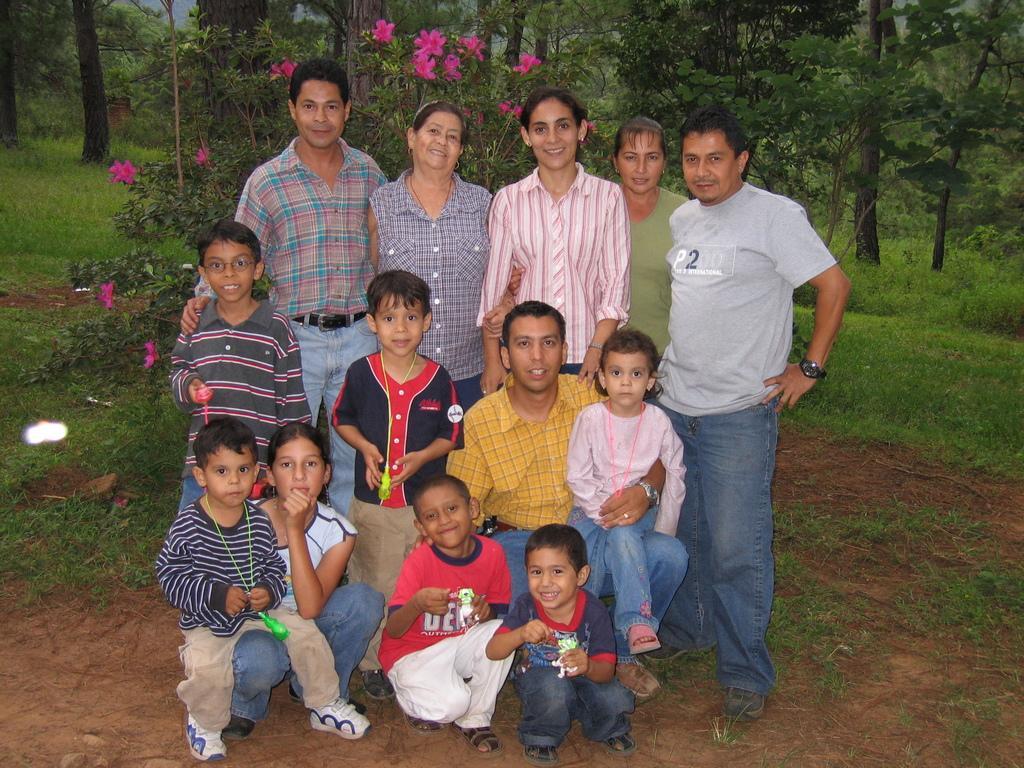In one or two sentences, can you explain what this image depicts? In the image we can see men, women and children's standing and some of them are sitting. They are wearing clothes and some of them are wearing shoes. The right side man is wearing a wrist watch. Here we can see grass, flower plant and trees. Here we can see flowers, pink in color. 